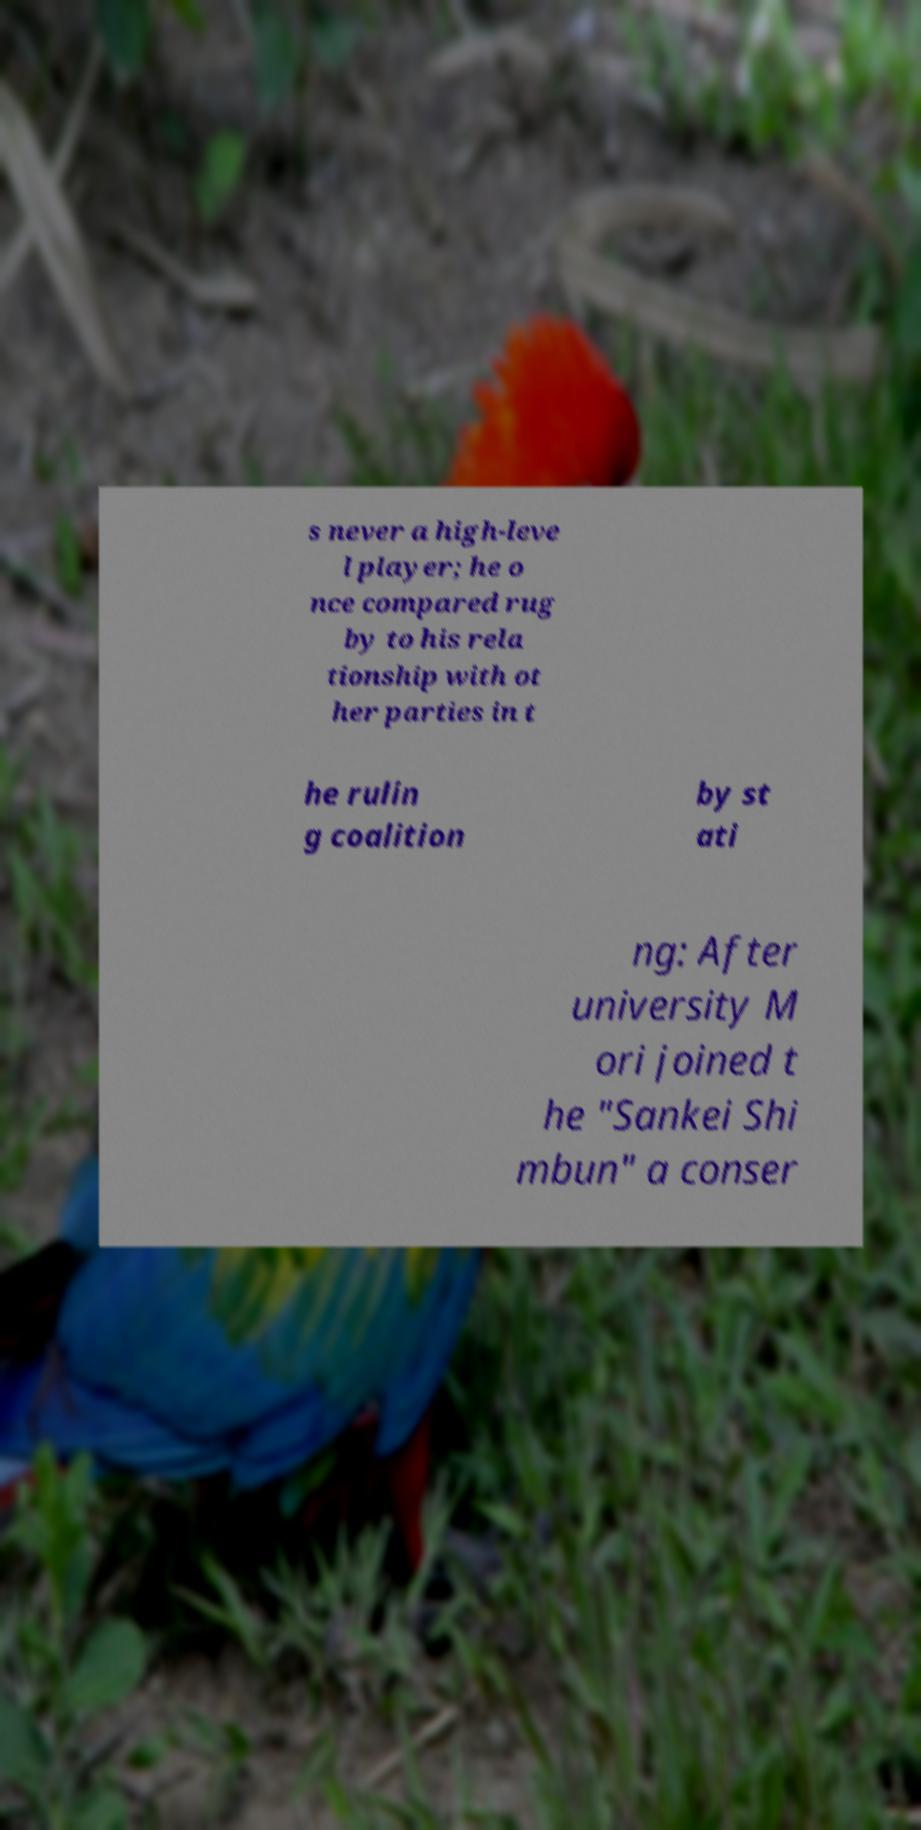Please identify and transcribe the text found in this image. s never a high-leve l player; he o nce compared rug by to his rela tionship with ot her parties in t he rulin g coalition by st ati ng: After university M ori joined t he "Sankei Shi mbun" a conser 